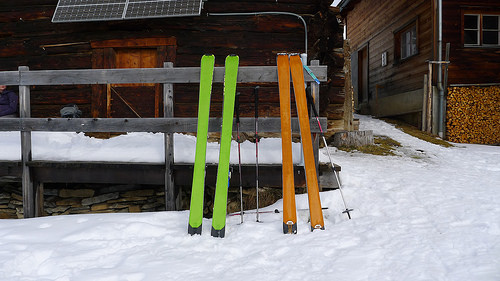<image>
Is the ski in front of the fence? Yes. The ski is positioned in front of the fence, appearing closer to the camera viewpoint. 